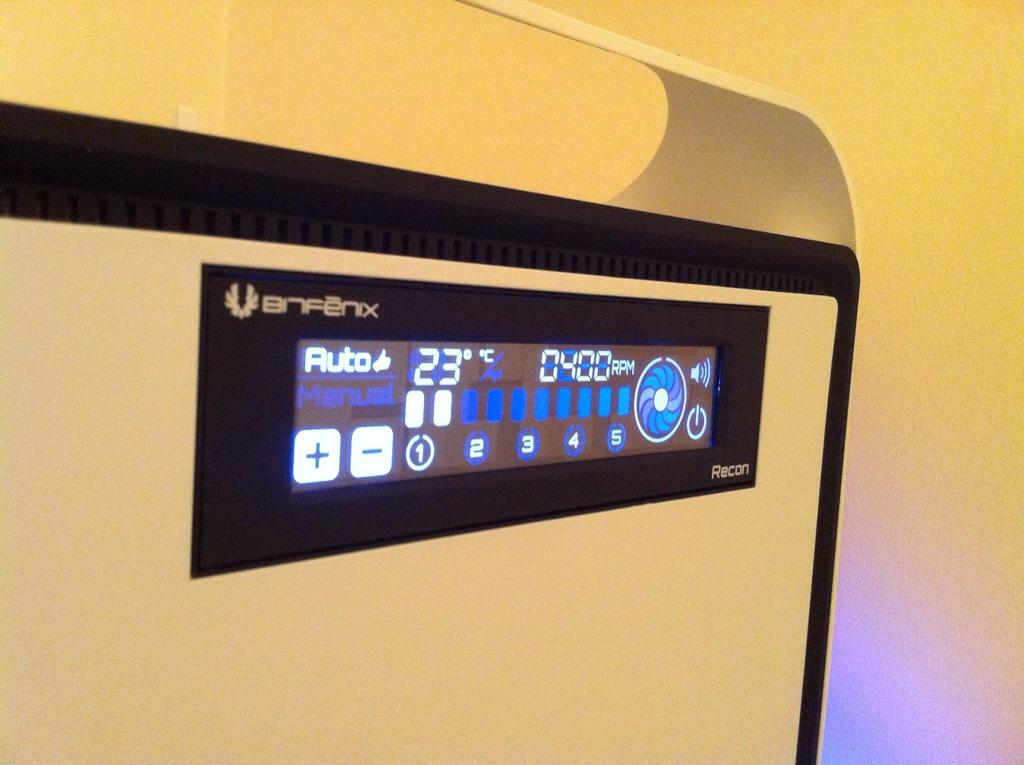Provide a one-sentence caption for the provided image. A digital display has a thumbs-up symbol next to the word auto. 